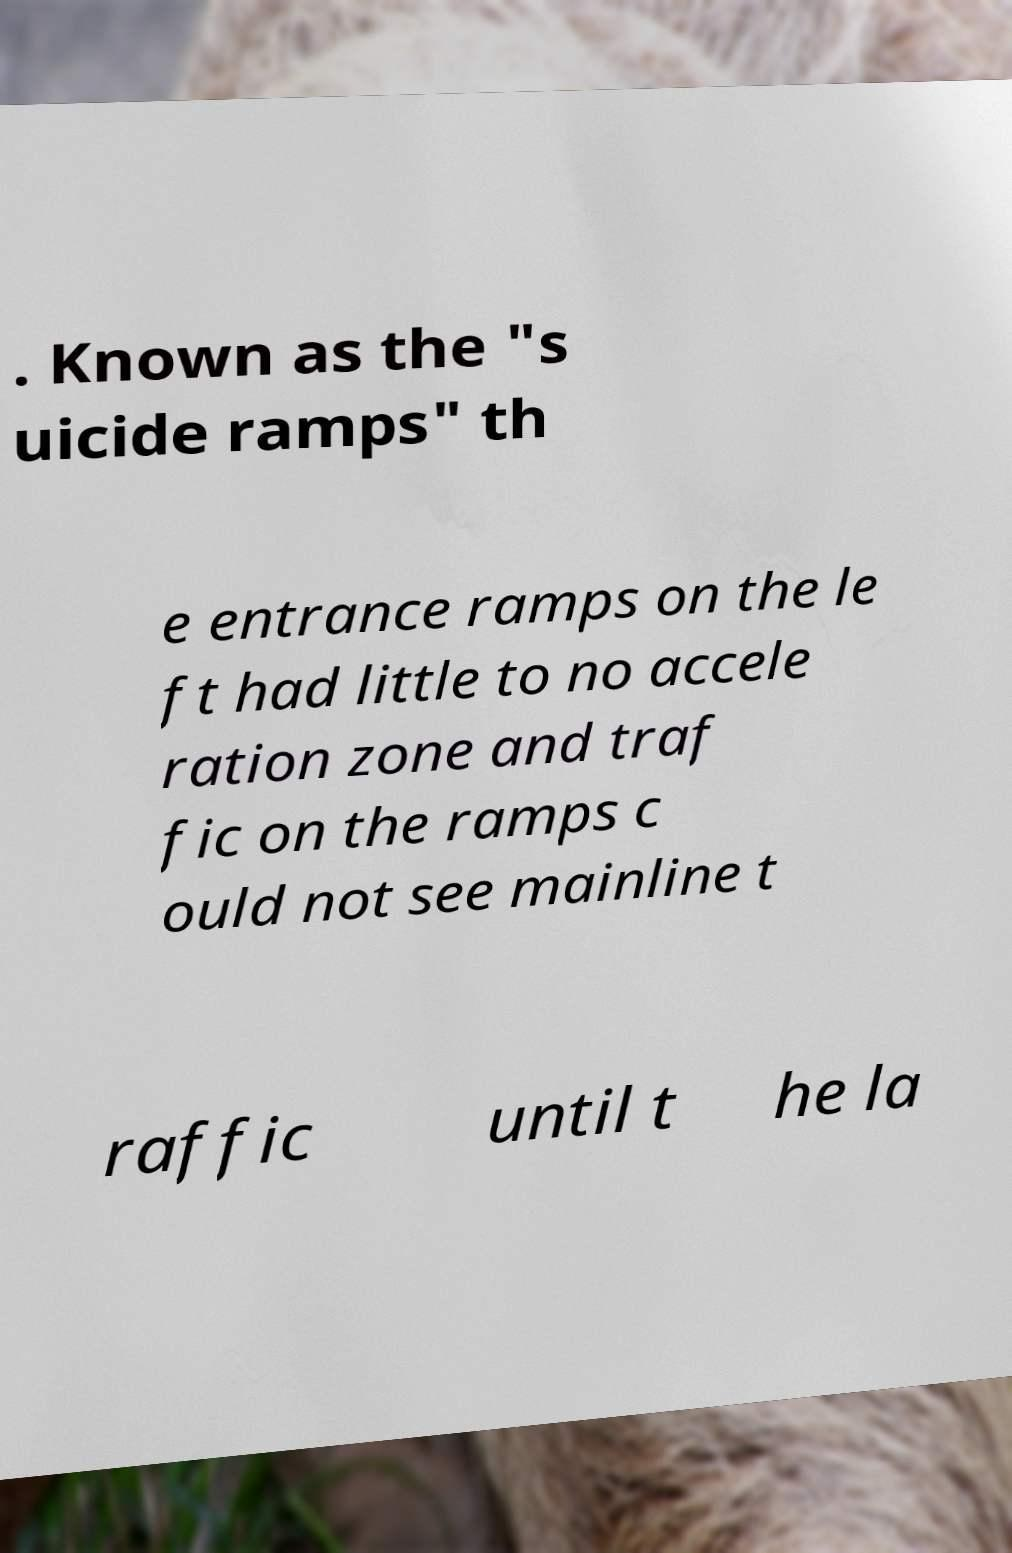What messages or text are displayed in this image? I need them in a readable, typed format. . Known as the "s uicide ramps" th e entrance ramps on the le ft had little to no accele ration zone and traf fic on the ramps c ould not see mainline t raffic until t he la 